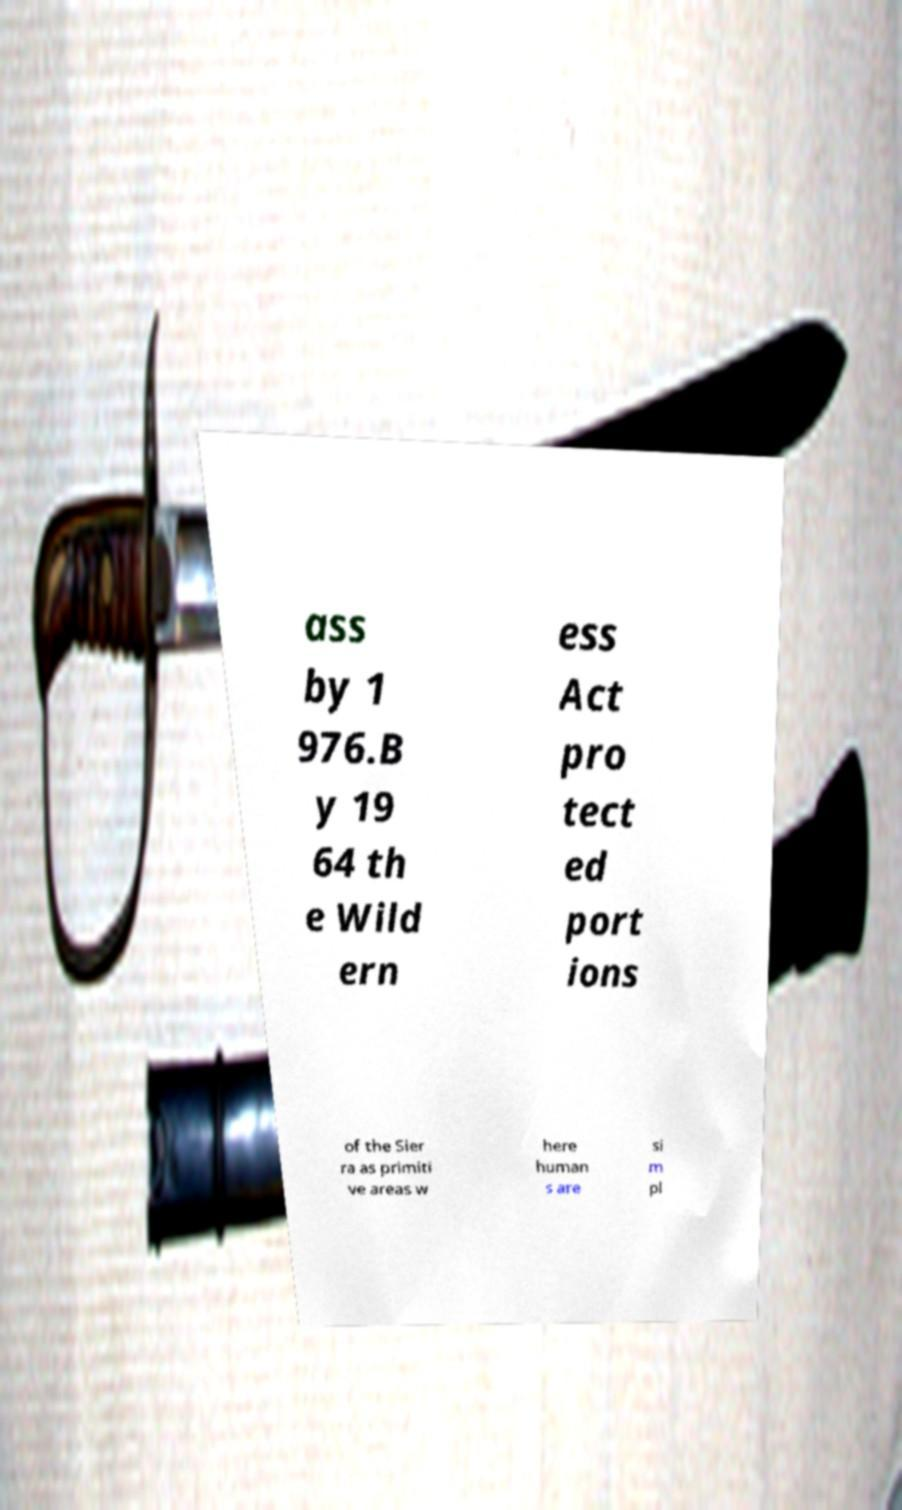What messages or text are displayed in this image? I need them in a readable, typed format. ass by 1 976.B y 19 64 th e Wild ern ess Act pro tect ed port ions of the Sier ra as primiti ve areas w here human s are si m pl 